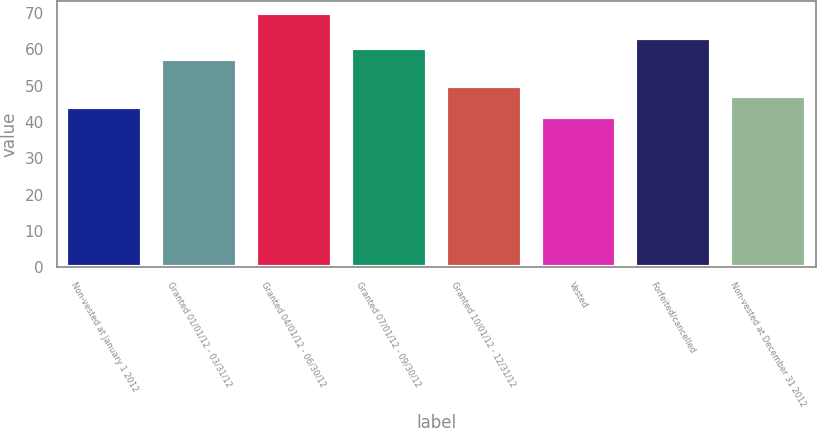Convert chart. <chart><loc_0><loc_0><loc_500><loc_500><bar_chart><fcel>Non-vested at January 1 2012<fcel>Granted 01/01/12 - 03/31/12<fcel>Granted 04/01/12 - 06/30/12<fcel>Granted 07/01/12 - 09/30/12<fcel>Granted 10/01/12 - 12/31/12<fcel>Vested<fcel>Forfeited/cancelled<fcel>Non-vested at December 31 2012<nl><fcel>44.28<fcel>57.45<fcel>69.98<fcel>60.31<fcel>50<fcel>41.43<fcel>63.17<fcel>47.14<nl></chart> 